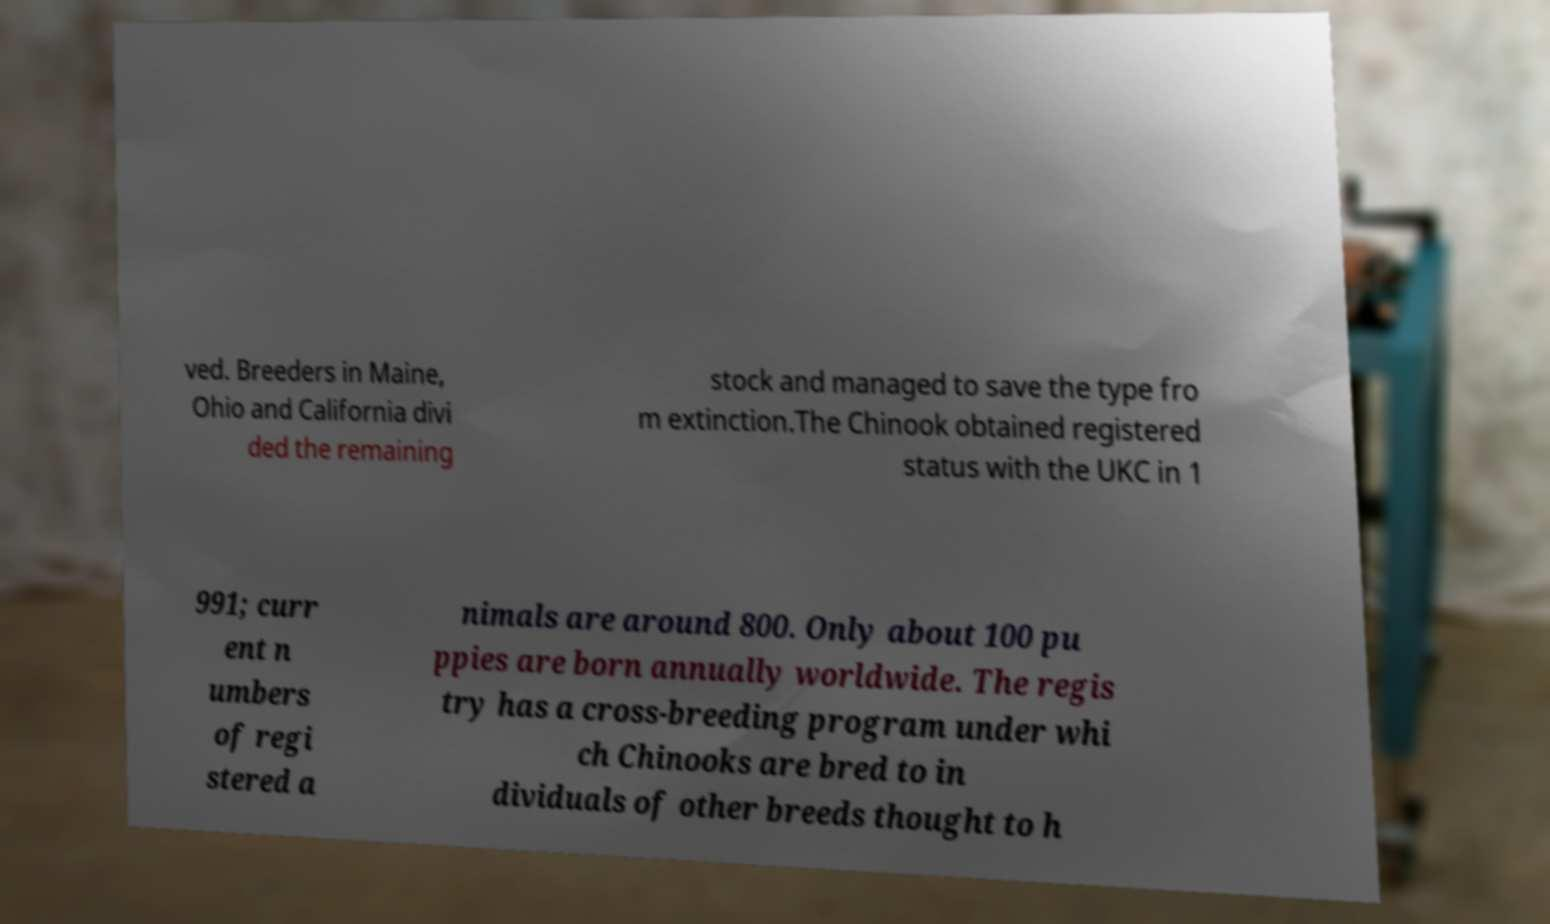Please identify and transcribe the text found in this image. ved. Breeders in Maine, Ohio and California divi ded the remaining stock and managed to save the type fro m extinction.The Chinook obtained registered status with the UKC in 1 991; curr ent n umbers of regi stered a nimals are around 800. Only about 100 pu ppies are born annually worldwide. The regis try has a cross-breeding program under whi ch Chinooks are bred to in dividuals of other breeds thought to h 